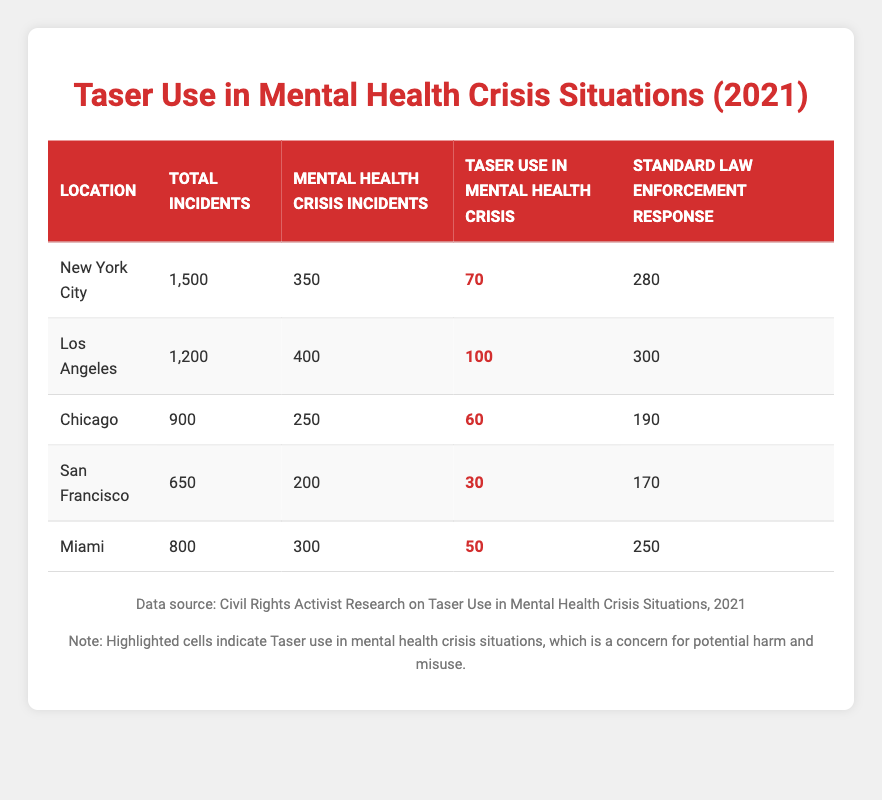What is the total number of incidents reported in Los Angeles? The table indicates that the total incidents reported in Los Angeles is 1,200.
Answer: 1,200 What location had the highest number of mental health crisis incidents? By comparing the values for mental health crisis incidents across all locations, Los Angeles has the highest with 400 incidents.
Answer: Los Angeles What is the total number of taser uses in mental health crisis situations across all locations combined? Summing the taser use in mental health crisis situations from all locations yields (70 + 100 + 60 + 30 + 50) = 310.
Answer: 310 Is the number of taser uses in mental health crisis situations higher in New York City than in Miami? In New York City, there are 70 taser uses, compared to 50 in Miami, meaning yes, New York City has a higher number.
Answer: Yes How many more standard law enforcement responses were there in Chicago compared to San Francisco? The standard law enforcement responses in Chicago is 190, while in San Francisco it is 170. The difference is (190 - 170) = 20.
Answer: 20 What percentage of mental health crisis incidents in New York City involved taser use? Calculating the percentage involves (taser use in mental health crisis incidents / total mental health crisis incidents) x 100, which is (70 / 350) x 100 = 20%.
Answer: 20% Which location has the lowest number of taser uses in mental health crisis situations? By reviewing the taser use data for all locations, San Francisco shows the lowest usage with 30 taser applications.
Answer: San Francisco What is the average number of taser uses in mental health crisis situations across all locations? The average is calculated as the sum of taser uses (310) divided by the number of locations (5), which gives 310 / 5 = 62.
Answer: 62 Did Miami experience more mental health crisis incidents than Chicago in 2021? Miami had 300 mental health crisis incidents, while Chicago had 250, indicating that yes, Miami had more incidents.
Answer: Yes 